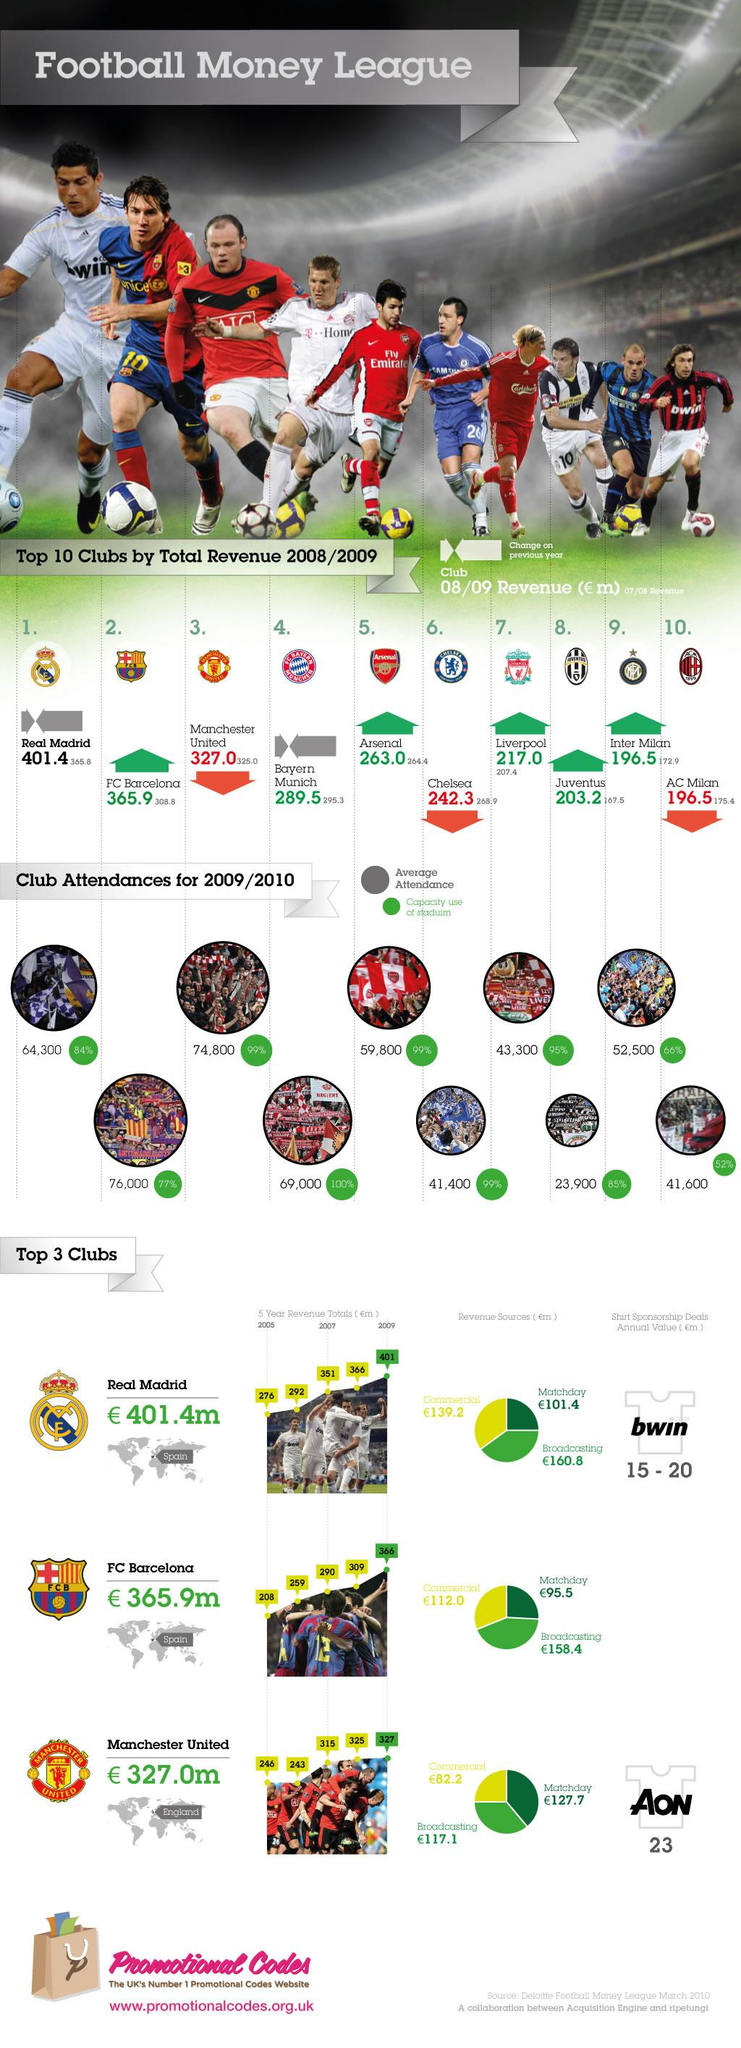Point out several critical features in this image. The total revenue generated by Manchester United in 2006 was 243 million euros. In the 2008/2009 season, the Liverpool football club generated a total revenue of 217 million euros. Real Madrid generated the highest revenue among football clubs in the 2008/2009 season. The average attendance for Liverpool F.C. games in the 2009/2010 season was approximately 43,300. In the 2008/2009 season, the total revenue generated by Chelsea Football Club was approximately 242.3 million euros. 